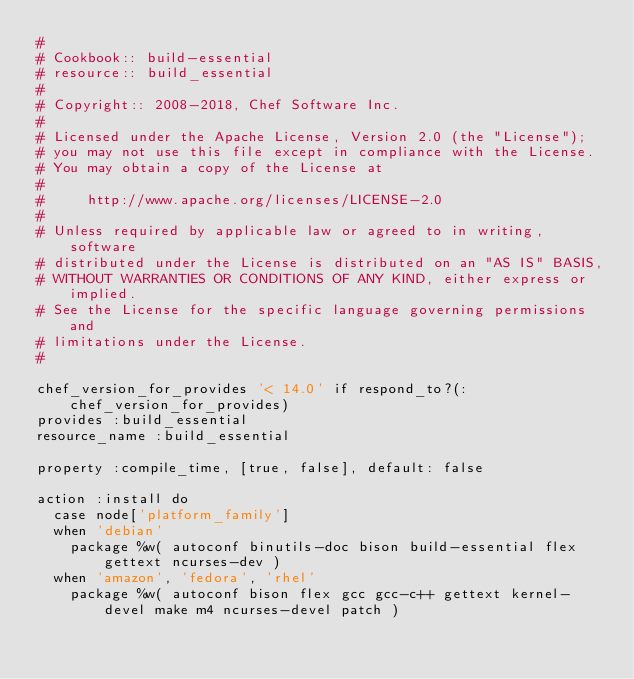Convert code to text. <code><loc_0><loc_0><loc_500><loc_500><_Ruby_>#
# Cookbook:: build-essential
# resource:: build_essential
#
# Copyright:: 2008-2018, Chef Software Inc.
#
# Licensed under the Apache License, Version 2.0 (the "License");
# you may not use this file except in compliance with the License.
# You may obtain a copy of the License at
#
#     http://www.apache.org/licenses/LICENSE-2.0
#
# Unless required by applicable law or agreed to in writing, software
# distributed under the License is distributed on an "AS IS" BASIS,
# WITHOUT WARRANTIES OR CONDITIONS OF ANY KIND, either express or implied.
# See the License for the specific language governing permissions and
# limitations under the License.
#

chef_version_for_provides '< 14.0' if respond_to?(:chef_version_for_provides)
provides :build_essential
resource_name :build_essential

property :compile_time, [true, false], default: false

action :install do
  case node['platform_family']
  when 'debian'
    package %w( autoconf binutils-doc bison build-essential flex gettext ncurses-dev )
  when 'amazon', 'fedora', 'rhel'
    package %w( autoconf bison flex gcc gcc-c++ gettext kernel-devel make m4 ncurses-devel patch )
</code> 